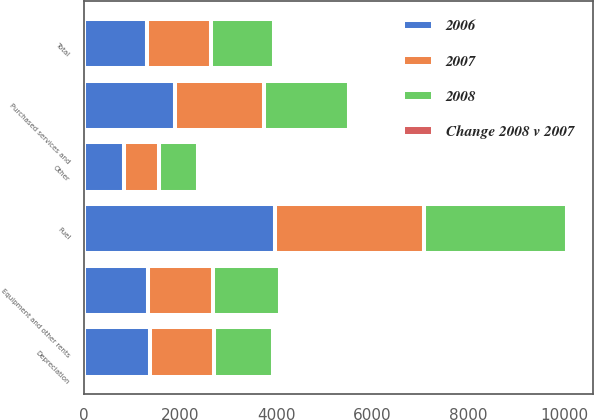<chart> <loc_0><loc_0><loc_500><loc_500><stacked_bar_chart><ecel><fcel>Fuel<fcel>Purchased services and<fcel>Depreciation<fcel>Equipment and other rents<fcel>Other<fcel>Total<nl><fcel>2006<fcel>3983<fcel>1902<fcel>1387<fcel>1326<fcel>840<fcel>1321<nl><fcel>2007<fcel>3104<fcel>1856<fcel>1321<fcel>1368<fcel>733<fcel>1321<nl><fcel>2008<fcel>2968<fcel>1756<fcel>1237<fcel>1396<fcel>802<fcel>1321<nl><fcel>Change 2008 v 2007<fcel>28<fcel>2<fcel>5<fcel>3<fcel>15<fcel>8<nl></chart> 